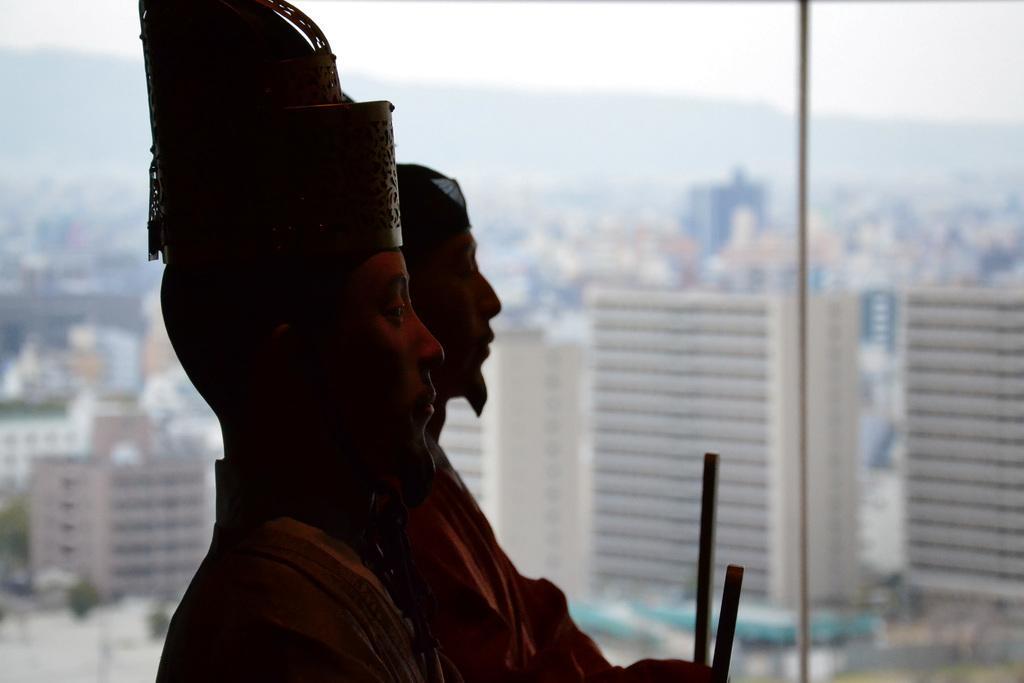Please provide a concise description of this image. In this picture we can see status of persons, here we can see rods, glass, from glass we can see buildings, mountains, sky. 